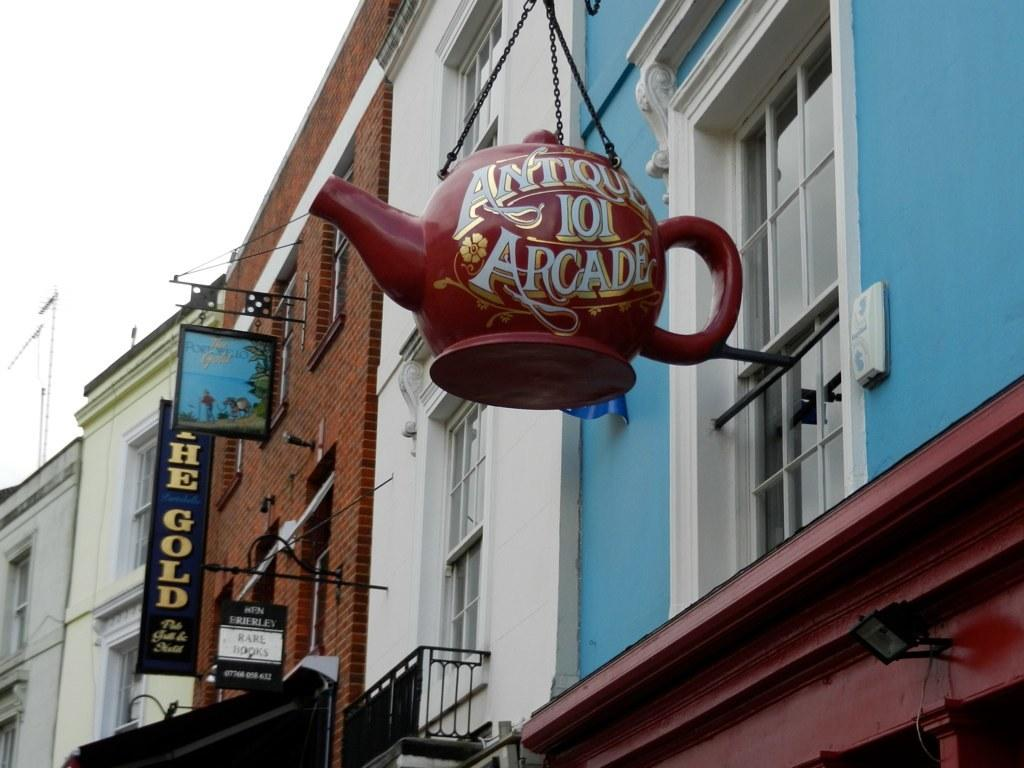What type of structures can be seen in the image? There are buildings in the image. What feature do the buildings have? The buildings have windows. What materials are present in the image? There are iron rods, boards, and chains in the image. What object in the image resembles a teapot? There is a teapot-shaped object in the image. What can be seen in the background of the image? The sky is visible behind the buildings. How many spots can be seen on the van in the image? There is no van present in the image; it features buildings, iron rods, boards, chains, and a teapot-shaped object. What type of yam is being used to hold the chains in the image? There is no yam present in the image; the chains are not being held by any yam. 